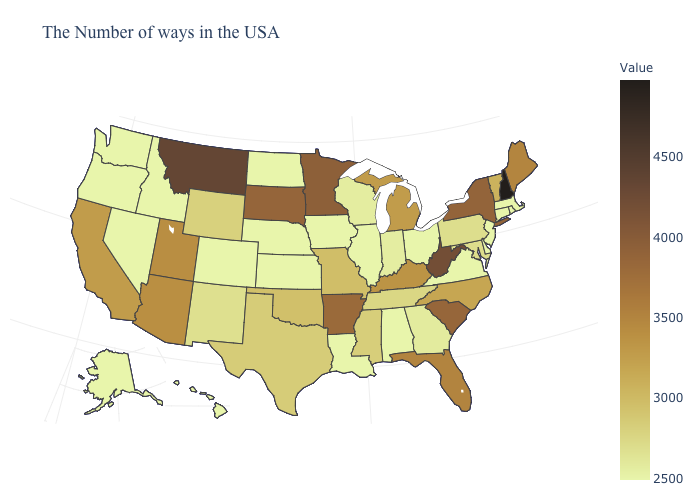Among the states that border North Carolina , does South Carolina have the highest value?
Concise answer only. Yes. Does Vermont have the lowest value in the USA?
Write a very short answer. No. Does Delaware have the lowest value in the South?
Be succinct. Yes. Which states hav the highest value in the West?
Answer briefly. Montana. 